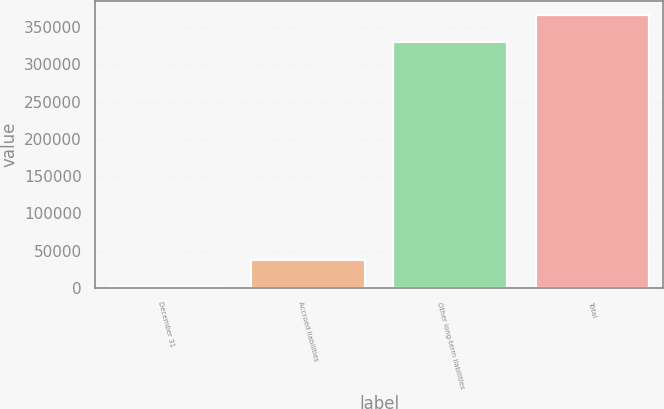Convert chart. <chart><loc_0><loc_0><loc_500><loc_500><bar_chart><fcel>December 31<fcel>Accrued liabilities<fcel>Other long-term liabilities<fcel>Total<nl><fcel>2007<fcel>38097.9<fcel>330708<fcel>366799<nl></chart> 